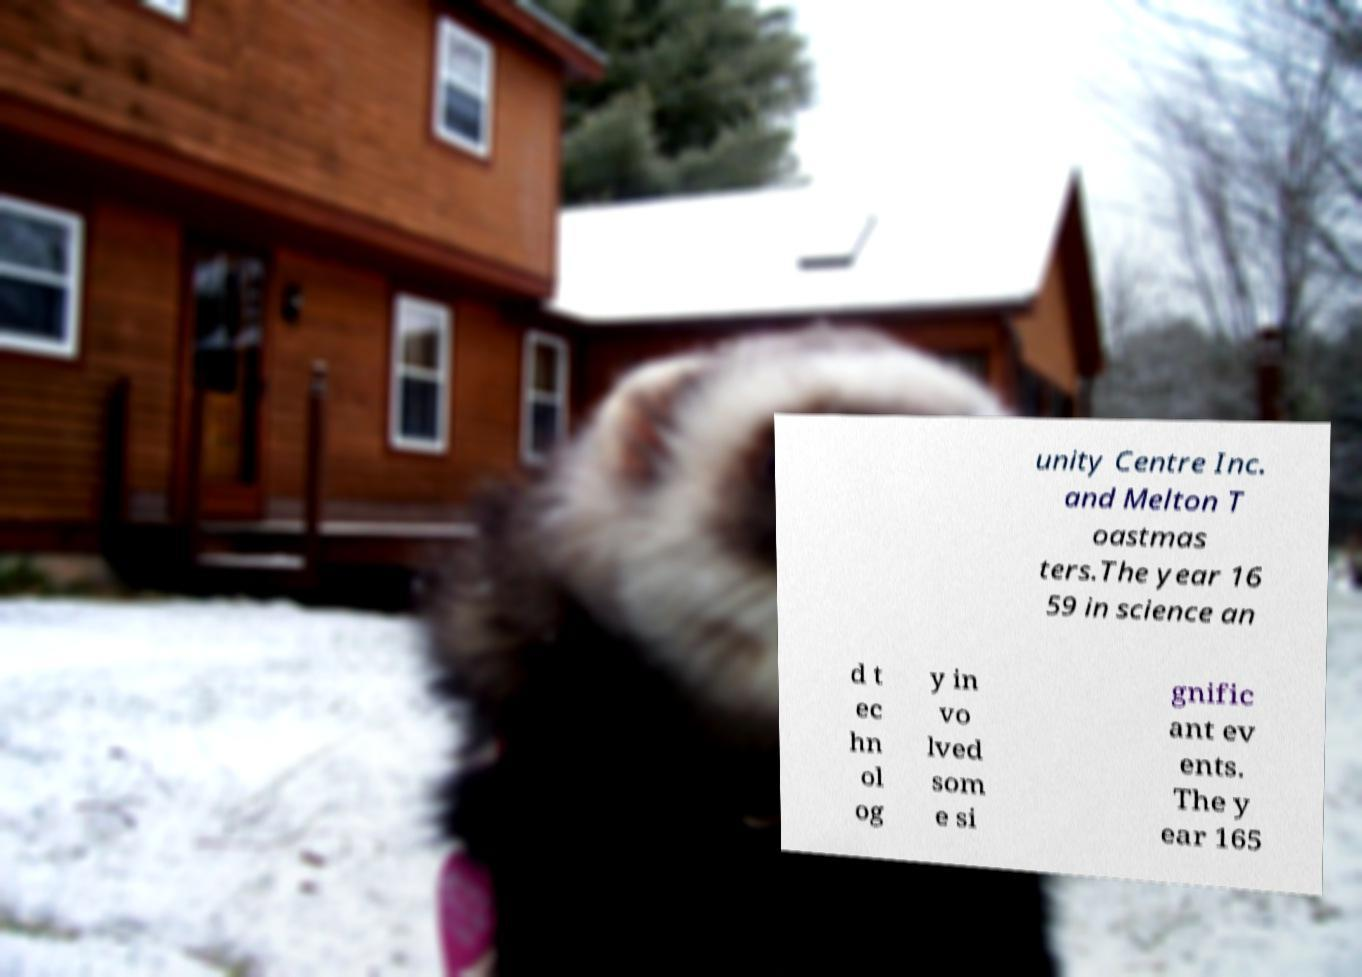Please read and relay the text visible in this image. What does it say? unity Centre Inc. and Melton T oastmas ters.The year 16 59 in science an d t ec hn ol og y in vo lved som e si gnific ant ev ents. The y ear 165 